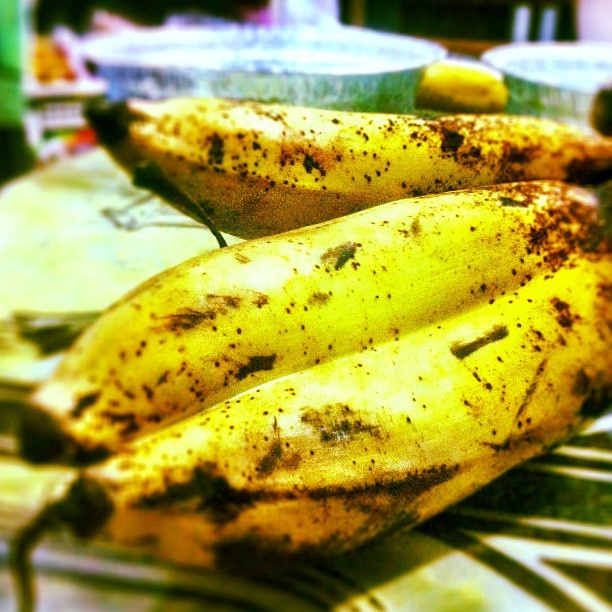Describe the objects in this image and their specific colors. I can see banana in lightgreen, yellow, olive, orange, and black tones, banana in lightgreen, yellow, gold, and olive tones, banana in lightgreen, olive, orange, and black tones, bowl in lightgreen, white, lightblue, and darkgray tones, and bowl in lightgreen, white, darkgray, olive, and green tones in this image. 